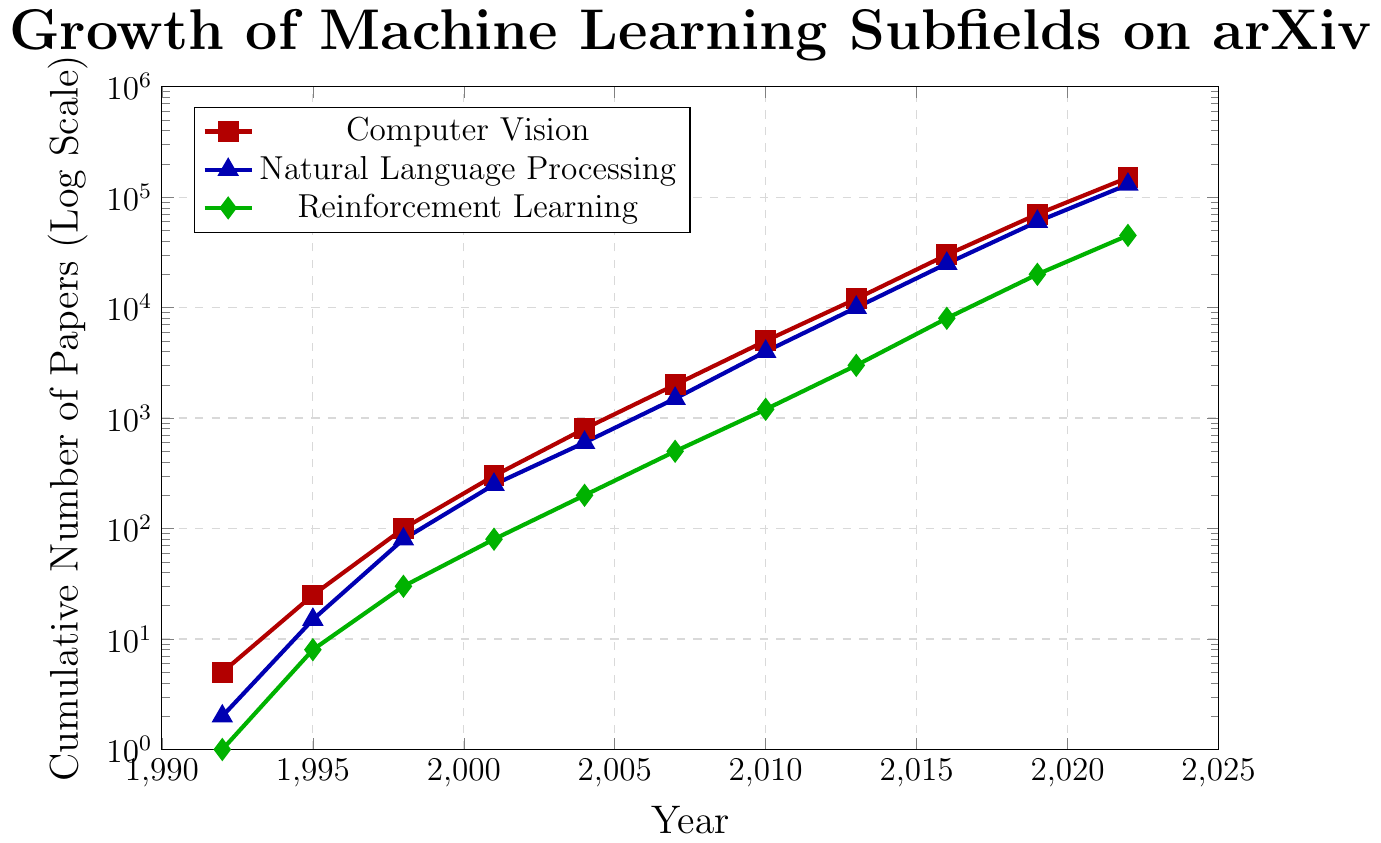What year did the cumulative number of papers in Computer Vision first exceed 10,000? By looking at the red line representing Computer Vision, find the first point where the y-value exceeds 10,000. This occurs in 2013 where the value is 12,000.
Answer: 2013 Which subfield had the slowest growth up until 2019? Compare the three lines and their progression. Reinforcement Learning (green) has consistently the lowest cumulative number of papers compared to Computer Vision (red) and Natural Language Processing (blue).
Answer: Reinforcement Learning Between 1998 and 2001, how much did the cumulative number of papers in Natural Language Processing increase? Look at the blue line at 1998 and 2001. Subtract the 1998 value (80) from the 2001 value (250). The difference is 250 - 80 = 170.
Answer: 170 What is the difference between the cumulative number of papers in Computer Vision and Reinforcement Learning in 2022? Look at the red and green lines at 2022. The values are 150,000 for Computer Vision and 45,000 for Reinforcement Learning. Subtract the Reinforcement Learning value from the Computer Vision value: 150,000 - 45,000 = 105,000.
Answer: 105,000 How many papers are there in Natural Language Processing relative to Computer Vision in 2007? Look at the blue and red lines at 2007. The blue line (Natural Language Processing) reads 1,500 and the red line (Computer Vision) reads 2,000. Calculate the ratio: 1,500 / 2,000 = 0.75.
Answer: 0.75 In which year did Reinforcement Learning first reach over 1,000 papers? Examine the green line on the y-axis for where it first surpasses 1,000. This happens in 2010, where the value is 1,200.
Answer: 2010 What was the combined cumulative number of papers in all three subfields in 2016? Add the values from all three lines for 2016. Computer Vision: 30,000; Natural Language Processing: 25,000; Reinforcement Learning: 8,000. Total is 30,000 + 25,000 + 8,000 = 63,000.
Answer: 63,000 Which subfield had the steepest growth from 2004 to 2007? Check the slopes of the lines between 2004 and 2007. The red (Computer Vision) line rises from 800 to 2,000, the blue (Natural Language Processing) from 600 to 1,500, and the green (Reinforcement Learning) from 200 to 500. Compute the differences: 1,200 for Computer Vision, 900 for Natural Language Processing, and 300 for Reinforcement Learning. The steepest growth is in Computer Vision.
Answer: Computer Vision By how much did the cumulative number of papers in Computer Vision increase from 2019 to 2022? Look at the red line for 2019 (70,000) and 2022 (150,000). Subtract 70,000 from 150,000, which gives 80,000.
Answer: 80,000 Which subfield caught up the most with Computer Vision from 1992 to 2022? Assess the relative growth of each of the subfields compared to Computer Vision from 1992 to 2022. In 1992, Computer Vision had 5 papers, NLP had 2, and RL had 1. By 2022, the numbers are 150,000 for Computer Vision, 130,000 for NLP, and 45,000 for RL. The catch-up growth for NLP is 130,000 - 2 = 129,998, compared to 44,999 for RL.
Answer: Natural Language Processing 